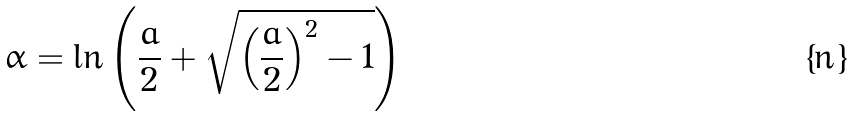<formula> <loc_0><loc_0><loc_500><loc_500>\alpha = \ln \left ( \frac { a } { 2 } + \sqrt { \left ( \frac { a } { 2 } \right ) ^ { 2 } - 1 } \right )</formula> 